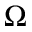<formula> <loc_0><loc_0><loc_500><loc_500>\Omega</formula> 